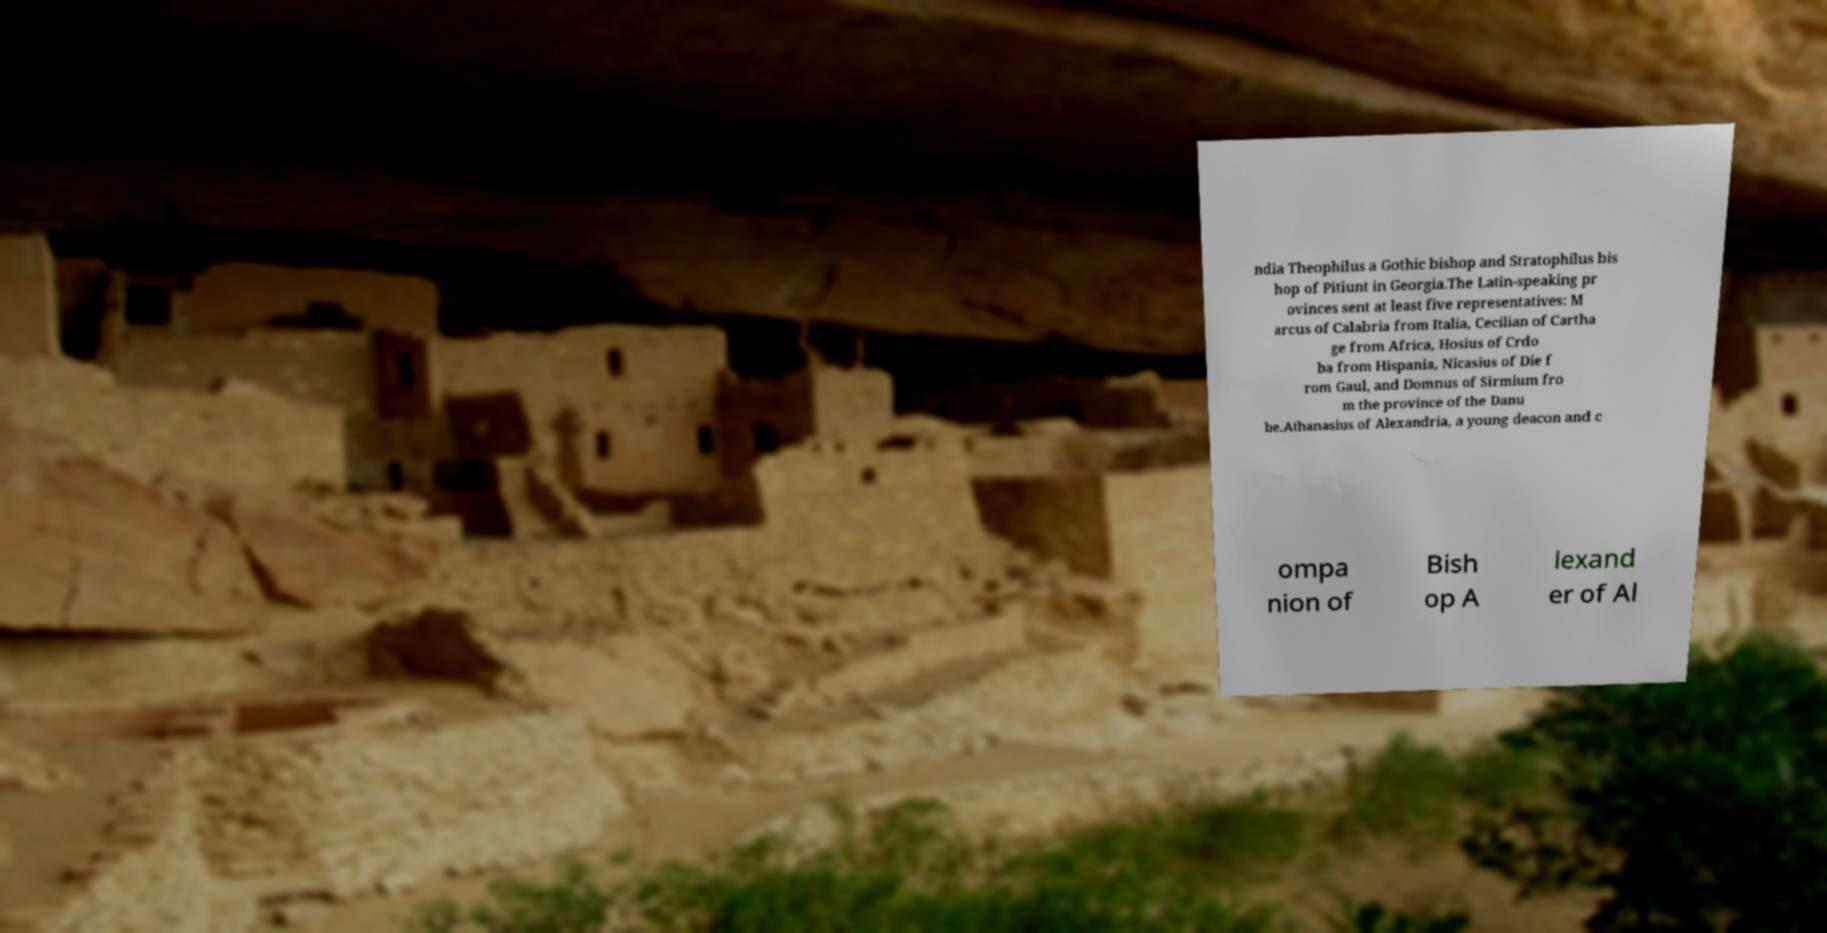Can you read and provide the text displayed in the image?This photo seems to have some interesting text. Can you extract and type it out for me? ndia Theophilus a Gothic bishop and Stratophilus bis hop of Pitiunt in Georgia.The Latin-speaking pr ovinces sent at least five representatives: M arcus of Calabria from Italia, Cecilian of Cartha ge from Africa, Hosius of Crdo ba from Hispania, Nicasius of Die f rom Gaul, and Domnus of Sirmium fro m the province of the Danu be.Athanasius of Alexandria, a young deacon and c ompa nion of Bish op A lexand er of Al 